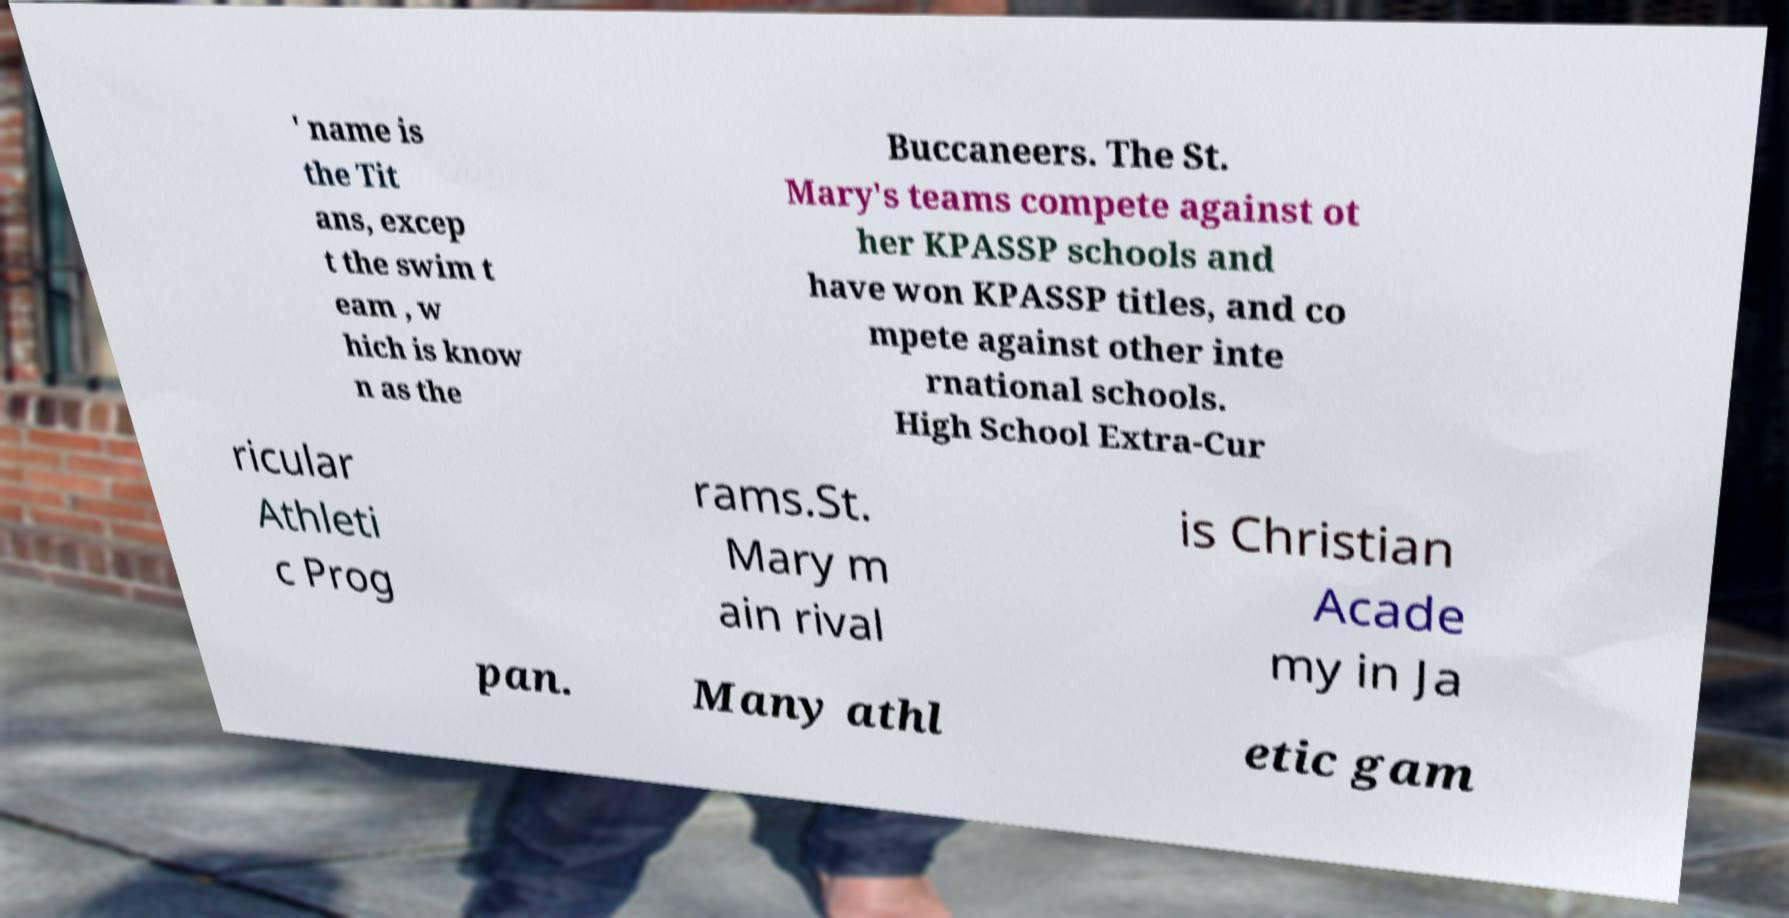Could you assist in decoding the text presented in this image and type it out clearly? ' name is the Tit ans, excep t the swim t eam , w hich is know n as the Buccaneers. The St. Mary's teams compete against ot her KPASSP schools and have won KPASSP titles, and co mpete against other inte rnational schools. High School Extra-Cur ricular Athleti c Prog rams.St. Mary m ain rival is Christian Acade my in Ja pan. Many athl etic gam 